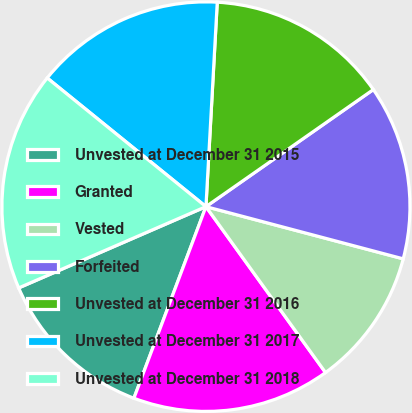Convert chart. <chart><loc_0><loc_0><loc_500><loc_500><pie_chart><fcel>Unvested at December 31 2015<fcel>Granted<fcel>Vested<fcel>Forfeited<fcel>Unvested at December 31 2016<fcel>Unvested at December 31 2017<fcel>Unvested at December 31 2018<nl><fcel>12.76%<fcel>15.71%<fcel>10.93%<fcel>13.79%<fcel>14.43%<fcel>15.07%<fcel>17.31%<nl></chart> 